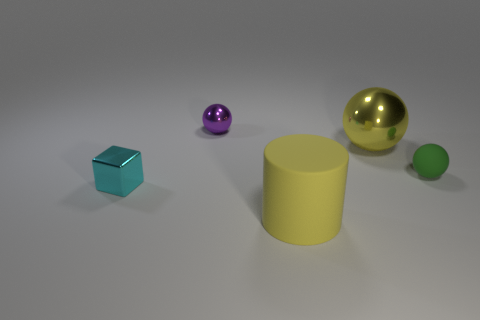There is a metal sphere that is the same color as the cylinder; what size is it?
Make the answer very short. Large. There is a sphere that is the same color as the cylinder; what is its material?
Your answer should be compact. Metal. Does the metallic sphere that is in front of the small shiny ball have the same color as the matte thing that is on the right side of the big shiny object?
Your answer should be very brief. No. What shape is the large object that is behind the small ball that is in front of the tiny shiny thing that is on the right side of the small cyan shiny block?
Your response must be concise. Sphere. What is the shape of the thing that is both behind the tiny matte sphere and to the left of the yellow ball?
Keep it short and to the point. Sphere. There is a small sphere to the right of the metal sphere that is behind the large yellow ball; what number of small metal things are in front of it?
Offer a terse response. 1. What is the size of the yellow metal thing that is the same shape as the tiny green rubber object?
Provide a succinct answer. Large. Is there any other thing that is the same size as the matte cylinder?
Offer a terse response. Yes. Does the yellow thing behind the cyan object have the same material as the cyan thing?
Keep it short and to the point. Yes. There is a tiny matte object that is the same shape as the yellow shiny object; what is its color?
Make the answer very short. Green. 